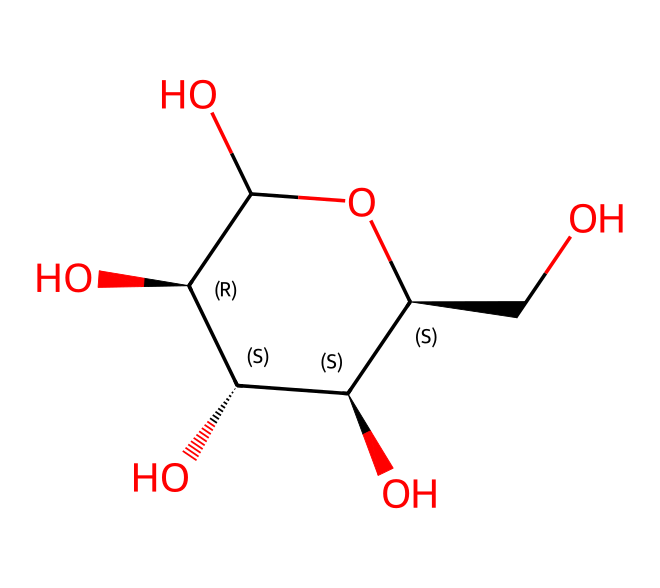What is the total number of carbon atoms in this chemical structure? By analyzing the SMILES representation, we can count the number of carbon atoms present. Each “C” in the SMILES indicates a carbon atom, and there are a total of six “C” characters representing carbon atoms in the structure.
Answer: six How many hydroxyl groups (–OH) are in this molecule? The presence of hydroxyl groups can be identified by examining the structure for oxygen atoms connected to hydrogen (–OH). In this case, there are four “O” atoms in the structure, each part of a hydroxyl group, showing that there are four hydroxyl groups present.
Answer: four What type of chemical is this compound classified as? Based on the presence of multiple hydroxyl groups, this compound is classified as a carbohydrate. Carbohydrates are typically composed of carbon, hydrogen, and oxygen, and the arrangement here indicates it fits within this category typified by sugars.
Answer: carbohydrate How many stereocenters are present in this molecule? To determine the stereocenters, we look for carbon atoms that are bonded to four distinct substituents. In this structure, there are four stereocenters as indicated by the chirality markers (@ and @@).
Answer: four What property does the high number of hydroxyl groups impart to this fiber? The high number of hydroxyl groups enhances the molecule's ability to form hydrogen bonds with water, thus improving solubility and water retention. This property is critical for biodegradable fibers as it enables them to interact favorably with the environment and decompose.
Answer: water solubility Is this fiber likely to be biodegradable, and why? Given the structure of this molecule with multiple hydroxyl groups and its classification as a carbohydrate, it is likely biodegradable. The presence of those groups facilitates microbial degradation, making it dissolve and break down in natural conditions effectively.
Answer: yes 